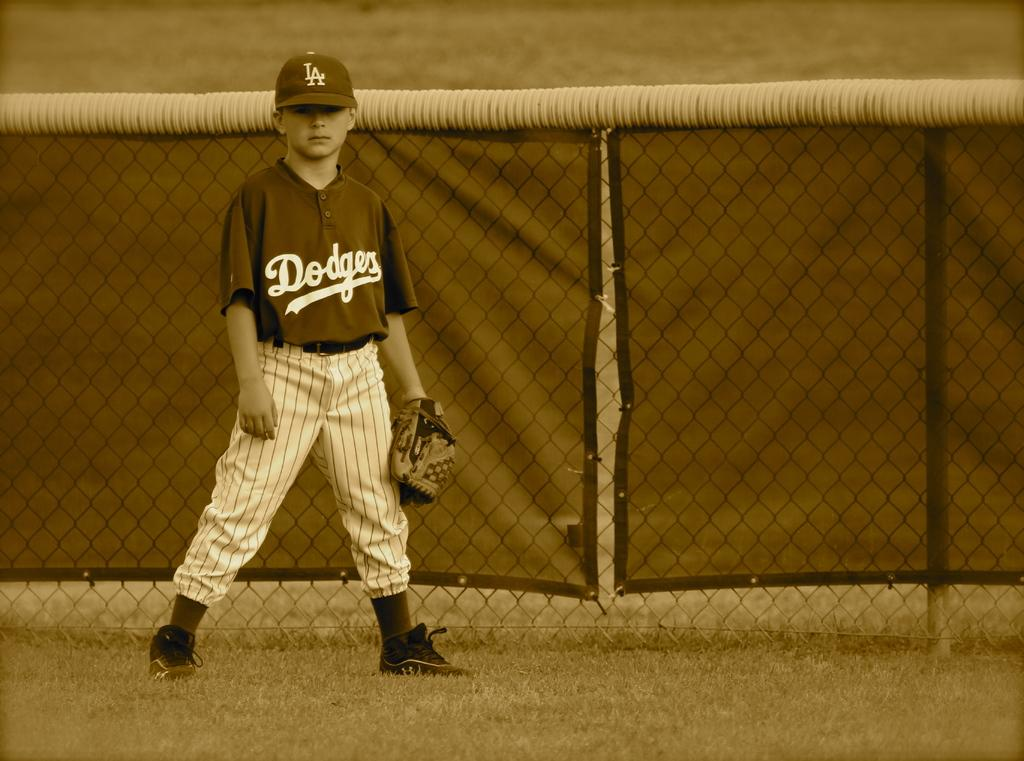<image>
Present a compact description of the photo's key features. A young baseball player with a Dodgers jersey on stands in the baseball field. 